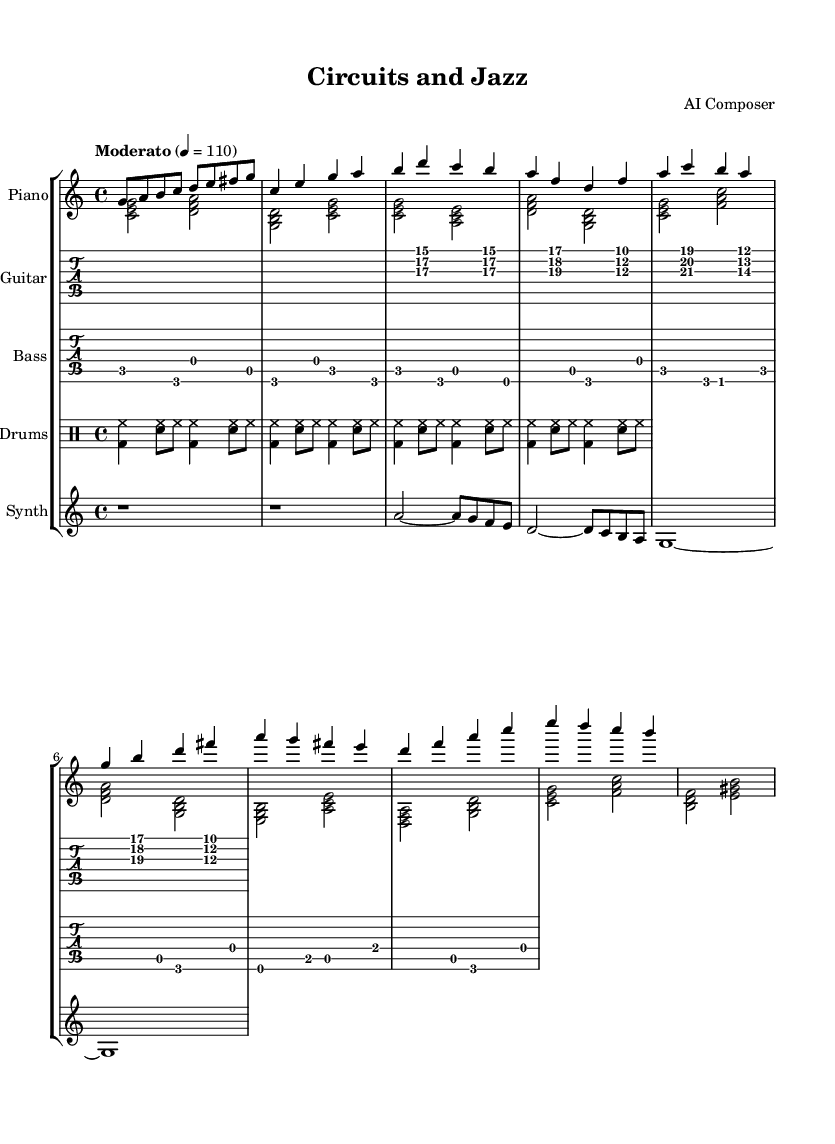What is the key signature of this music? The key signature appears at the beginning of the staff, showing one sharp (F#), indicating the piece is in the key of C major.
Answer: C major What is the time signature? The time signature is found at the beginning of the score and is indicated as 4/4, meaning there are four beats in each measure and the quarter note gets one beat.
Answer: 4/4 What is the tempo marking? The tempo is indicated at the beginning and reads “Moderato” with a metronome marking of 4 = 110, meaning a moderate pace at 110 beats per minute.
Answer: Moderato, 110 Which instrument plays the main theme first? The first instrument to present the main theme (Theme A) is the piano, as indicated by the notation that starts right after the initial intro section.
Answer: Piano What type of groove is featured in the drums part? Analyzing the drum part, the notation showcases a basic jazz fusion groove, combining bass drum, snare, and hi-hat hits in a syncopated pattern typical for jazz fusion styles.
Answer: Jazz fusion groove How many measures are in Theme A? Counting the measures indicated in the Theme A section for each instrument, there are a total of four distinct measures representing Theme A.
Answer: Four measures What electronic element is present in the composition? The score includes a synthesizer part that contributes electronic textures to the piece, showing the interdisciplinary aspect by blending acoustic and electronic sounds.
Answer: Synthesizer 